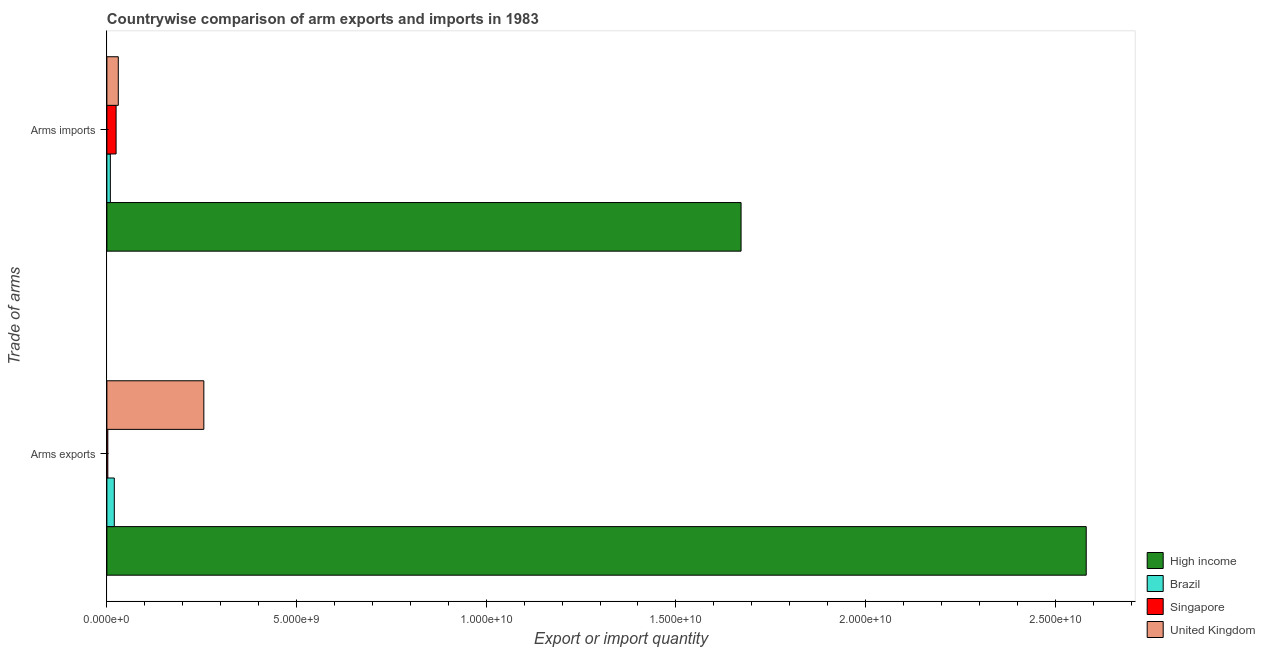How many groups of bars are there?
Your answer should be very brief. 2. How many bars are there on the 2nd tick from the bottom?
Offer a terse response. 4. What is the label of the 1st group of bars from the top?
Offer a terse response. Arms imports. What is the arms exports in Singapore?
Your response must be concise. 2.50e+07. Across all countries, what is the maximum arms exports?
Keep it short and to the point. 2.58e+1. Across all countries, what is the minimum arms exports?
Offer a very short reply. 2.50e+07. In which country was the arms exports minimum?
Provide a short and direct response. Singapore. What is the total arms imports in the graph?
Offer a terse response. 1.74e+1. What is the difference between the arms imports in High income and that in Singapore?
Your answer should be compact. 1.65e+1. What is the difference between the arms exports in United Kingdom and the arms imports in High income?
Your answer should be compact. -1.42e+1. What is the average arms exports per country?
Keep it short and to the point. 7.15e+09. What is the difference between the arms exports and arms imports in High income?
Provide a succinct answer. 9.10e+09. In how many countries, is the arms exports greater than 5000000000 ?
Offer a terse response. 1. What is the ratio of the arms exports in Singapore to that in United Kingdom?
Ensure brevity in your answer.  0.01. What does the 2nd bar from the top in Arms exports represents?
Keep it short and to the point. Singapore. What does the 3rd bar from the bottom in Arms imports represents?
Your response must be concise. Singapore. How many bars are there?
Give a very brief answer. 8. Are all the bars in the graph horizontal?
Provide a short and direct response. Yes. How many countries are there in the graph?
Your answer should be compact. 4. Are the values on the major ticks of X-axis written in scientific E-notation?
Provide a short and direct response. Yes. Does the graph contain any zero values?
Keep it short and to the point. No. How many legend labels are there?
Your answer should be very brief. 4. How are the legend labels stacked?
Your response must be concise. Vertical. What is the title of the graph?
Provide a succinct answer. Countrywise comparison of arm exports and imports in 1983. Does "Puerto Rico" appear as one of the legend labels in the graph?
Make the answer very short. No. What is the label or title of the X-axis?
Provide a succinct answer. Export or import quantity. What is the label or title of the Y-axis?
Offer a terse response. Trade of arms. What is the Export or import quantity of High income in Arms exports?
Give a very brief answer. 2.58e+1. What is the Export or import quantity in Brazil in Arms exports?
Provide a short and direct response. 1.96e+08. What is the Export or import quantity of Singapore in Arms exports?
Your answer should be compact. 2.50e+07. What is the Export or import quantity in United Kingdom in Arms exports?
Make the answer very short. 2.56e+09. What is the Export or import quantity of High income in Arms imports?
Keep it short and to the point. 1.67e+1. What is the Export or import quantity of Brazil in Arms imports?
Provide a succinct answer. 9.20e+07. What is the Export or import quantity of Singapore in Arms imports?
Offer a very short reply. 2.43e+08. What is the Export or import quantity in United Kingdom in Arms imports?
Provide a succinct answer. 3.01e+08. Across all Trade of arms, what is the maximum Export or import quantity in High income?
Offer a very short reply. 2.58e+1. Across all Trade of arms, what is the maximum Export or import quantity of Brazil?
Give a very brief answer. 1.96e+08. Across all Trade of arms, what is the maximum Export or import quantity in Singapore?
Your answer should be very brief. 2.43e+08. Across all Trade of arms, what is the maximum Export or import quantity of United Kingdom?
Provide a short and direct response. 2.56e+09. Across all Trade of arms, what is the minimum Export or import quantity of High income?
Keep it short and to the point. 1.67e+1. Across all Trade of arms, what is the minimum Export or import quantity in Brazil?
Ensure brevity in your answer.  9.20e+07. Across all Trade of arms, what is the minimum Export or import quantity of Singapore?
Offer a very short reply. 2.50e+07. Across all Trade of arms, what is the minimum Export or import quantity of United Kingdom?
Offer a terse response. 3.01e+08. What is the total Export or import quantity in High income in the graph?
Ensure brevity in your answer.  4.25e+1. What is the total Export or import quantity in Brazil in the graph?
Make the answer very short. 2.88e+08. What is the total Export or import quantity in Singapore in the graph?
Your answer should be compact. 2.68e+08. What is the total Export or import quantity in United Kingdom in the graph?
Provide a succinct answer. 2.86e+09. What is the difference between the Export or import quantity of High income in Arms exports and that in Arms imports?
Offer a terse response. 9.10e+09. What is the difference between the Export or import quantity in Brazil in Arms exports and that in Arms imports?
Provide a short and direct response. 1.04e+08. What is the difference between the Export or import quantity of Singapore in Arms exports and that in Arms imports?
Give a very brief answer. -2.18e+08. What is the difference between the Export or import quantity of United Kingdom in Arms exports and that in Arms imports?
Your answer should be very brief. 2.26e+09. What is the difference between the Export or import quantity in High income in Arms exports and the Export or import quantity in Brazil in Arms imports?
Offer a terse response. 2.57e+1. What is the difference between the Export or import quantity in High income in Arms exports and the Export or import quantity in Singapore in Arms imports?
Provide a short and direct response. 2.56e+1. What is the difference between the Export or import quantity in High income in Arms exports and the Export or import quantity in United Kingdom in Arms imports?
Ensure brevity in your answer.  2.55e+1. What is the difference between the Export or import quantity of Brazil in Arms exports and the Export or import quantity of Singapore in Arms imports?
Your response must be concise. -4.70e+07. What is the difference between the Export or import quantity in Brazil in Arms exports and the Export or import quantity in United Kingdom in Arms imports?
Ensure brevity in your answer.  -1.05e+08. What is the difference between the Export or import quantity of Singapore in Arms exports and the Export or import quantity of United Kingdom in Arms imports?
Your answer should be very brief. -2.76e+08. What is the average Export or import quantity of High income per Trade of arms?
Your answer should be very brief. 2.13e+1. What is the average Export or import quantity of Brazil per Trade of arms?
Your answer should be very brief. 1.44e+08. What is the average Export or import quantity of Singapore per Trade of arms?
Give a very brief answer. 1.34e+08. What is the average Export or import quantity of United Kingdom per Trade of arms?
Your answer should be very brief. 1.43e+09. What is the difference between the Export or import quantity in High income and Export or import quantity in Brazil in Arms exports?
Your response must be concise. 2.56e+1. What is the difference between the Export or import quantity in High income and Export or import quantity in Singapore in Arms exports?
Your answer should be compact. 2.58e+1. What is the difference between the Export or import quantity of High income and Export or import quantity of United Kingdom in Arms exports?
Your answer should be very brief. 2.33e+1. What is the difference between the Export or import quantity of Brazil and Export or import quantity of Singapore in Arms exports?
Offer a terse response. 1.71e+08. What is the difference between the Export or import quantity of Brazil and Export or import quantity of United Kingdom in Arms exports?
Make the answer very short. -2.36e+09. What is the difference between the Export or import quantity of Singapore and Export or import quantity of United Kingdom in Arms exports?
Your answer should be compact. -2.53e+09. What is the difference between the Export or import quantity in High income and Export or import quantity in Brazil in Arms imports?
Your answer should be very brief. 1.66e+1. What is the difference between the Export or import quantity in High income and Export or import quantity in Singapore in Arms imports?
Provide a short and direct response. 1.65e+1. What is the difference between the Export or import quantity of High income and Export or import quantity of United Kingdom in Arms imports?
Give a very brief answer. 1.64e+1. What is the difference between the Export or import quantity in Brazil and Export or import quantity in Singapore in Arms imports?
Offer a terse response. -1.51e+08. What is the difference between the Export or import quantity of Brazil and Export or import quantity of United Kingdom in Arms imports?
Your answer should be very brief. -2.09e+08. What is the difference between the Export or import quantity in Singapore and Export or import quantity in United Kingdom in Arms imports?
Provide a short and direct response. -5.80e+07. What is the ratio of the Export or import quantity in High income in Arms exports to that in Arms imports?
Make the answer very short. 1.54. What is the ratio of the Export or import quantity in Brazil in Arms exports to that in Arms imports?
Ensure brevity in your answer.  2.13. What is the ratio of the Export or import quantity in Singapore in Arms exports to that in Arms imports?
Your answer should be compact. 0.1. What is the ratio of the Export or import quantity of United Kingdom in Arms exports to that in Arms imports?
Give a very brief answer. 8.49. What is the difference between the highest and the second highest Export or import quantity in High income?
Your response must be concise. 9.10e+09. What is the difference between the highest and the second highest Export or import quantity in Brazil?
Ensure brevity in your answer.  1.04e+08. What is the difference between the highest and the second highest Export or import quantity in Singapore?
Offer a terse response. 2.18e+08. What is the difference between the highest and the second highest Export or import quantity in United Kingdom?
Your response must be concise. 2.26e+09. What is the difference between the highest and the lowest Export or import quantity of High income?
Offer a terse response. 9.10e+09. What is the difference between the highest and the lowest Export or import quantity in Brazil?
Provide a succinct answer. 1.04e+08. What is the difference between the highest and the lowest Export or import quantity in Singapore?
Your answer should be compact. 2.18e+08. What is the difference between the highest and the lowest Export or import quantity in United Kingdom?
Give a very brief answer. 2.26e+09. 